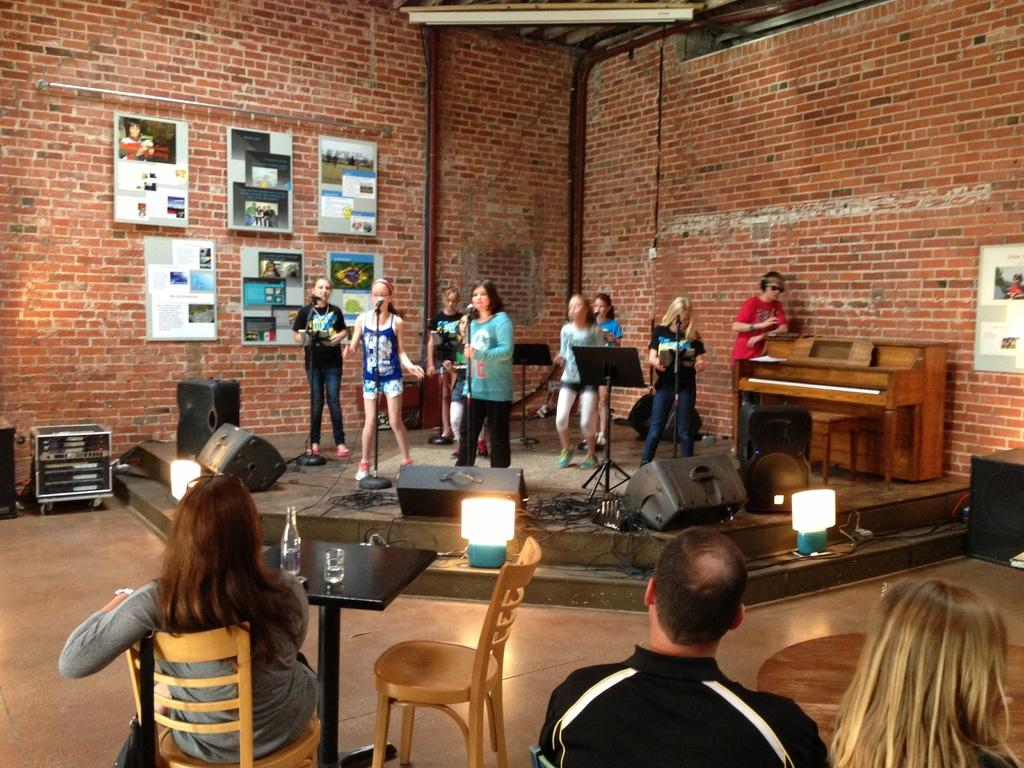What are the people in the image doing? There are people singing in the image, and some people are performing. Can you describe the man in the image? There is a man standing in the image. What is the audience doing in the image? The audience is seated and watching the show. What type of silk is being used by the lawyer in the image? There is no lawyer or silk present in the image. 